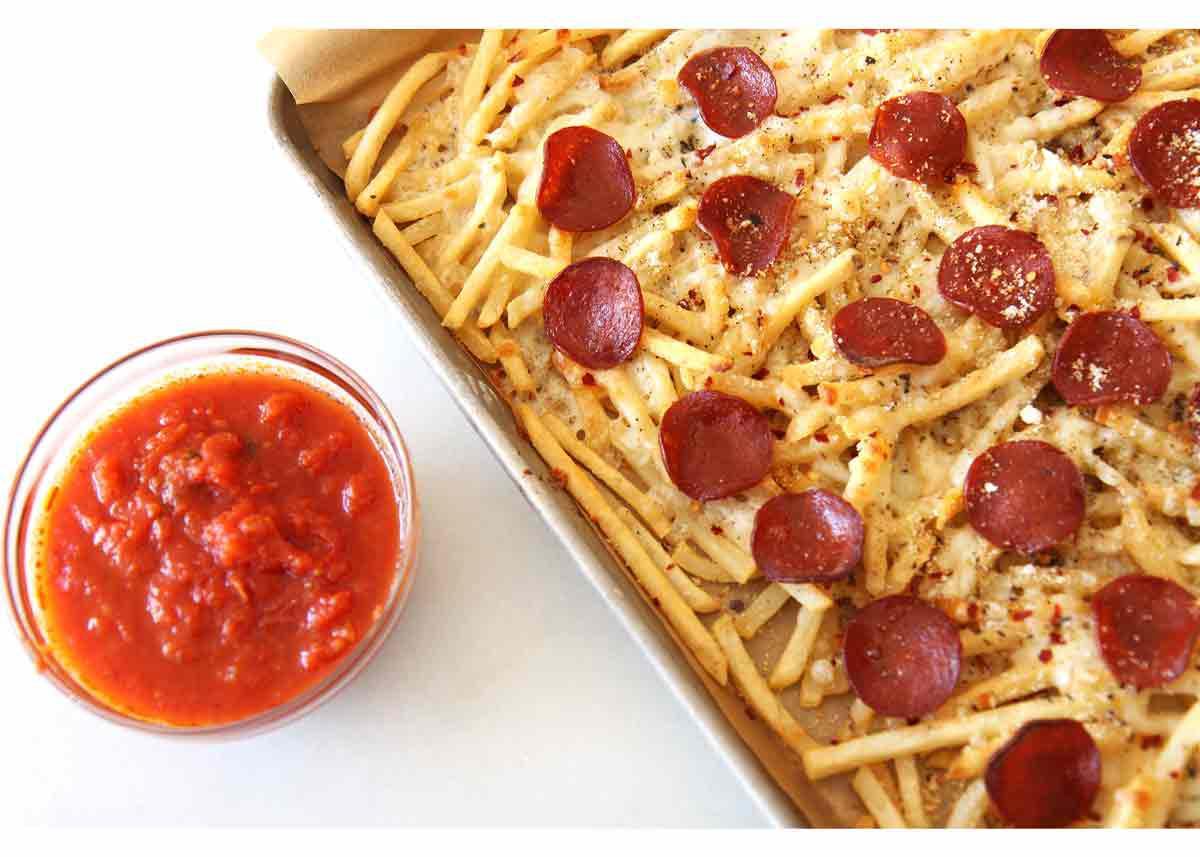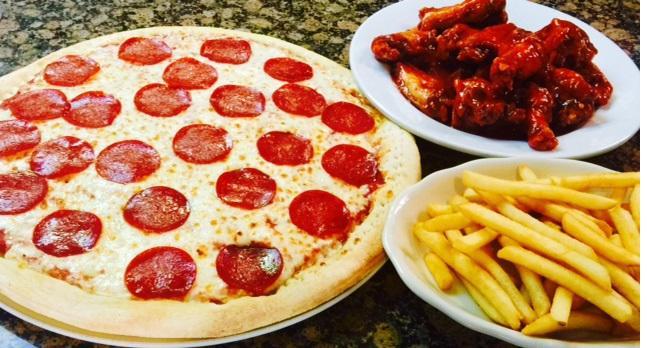The first image is the image on the left, the second image is the image on the right. Considering the images on both sides, is "The left image shows a round bowl of red-orange sauce next to but not touching a rectangular pan containing french fries with pepperonis on top." valid? Answer yes or no. Yes. The first image is the image on the left, the second image is the image on the right. Analyze the images presented: Is the assertion "The right image contains one order of pizza fries and one ramekin of marinara." valid? Answer yes or no. No. 